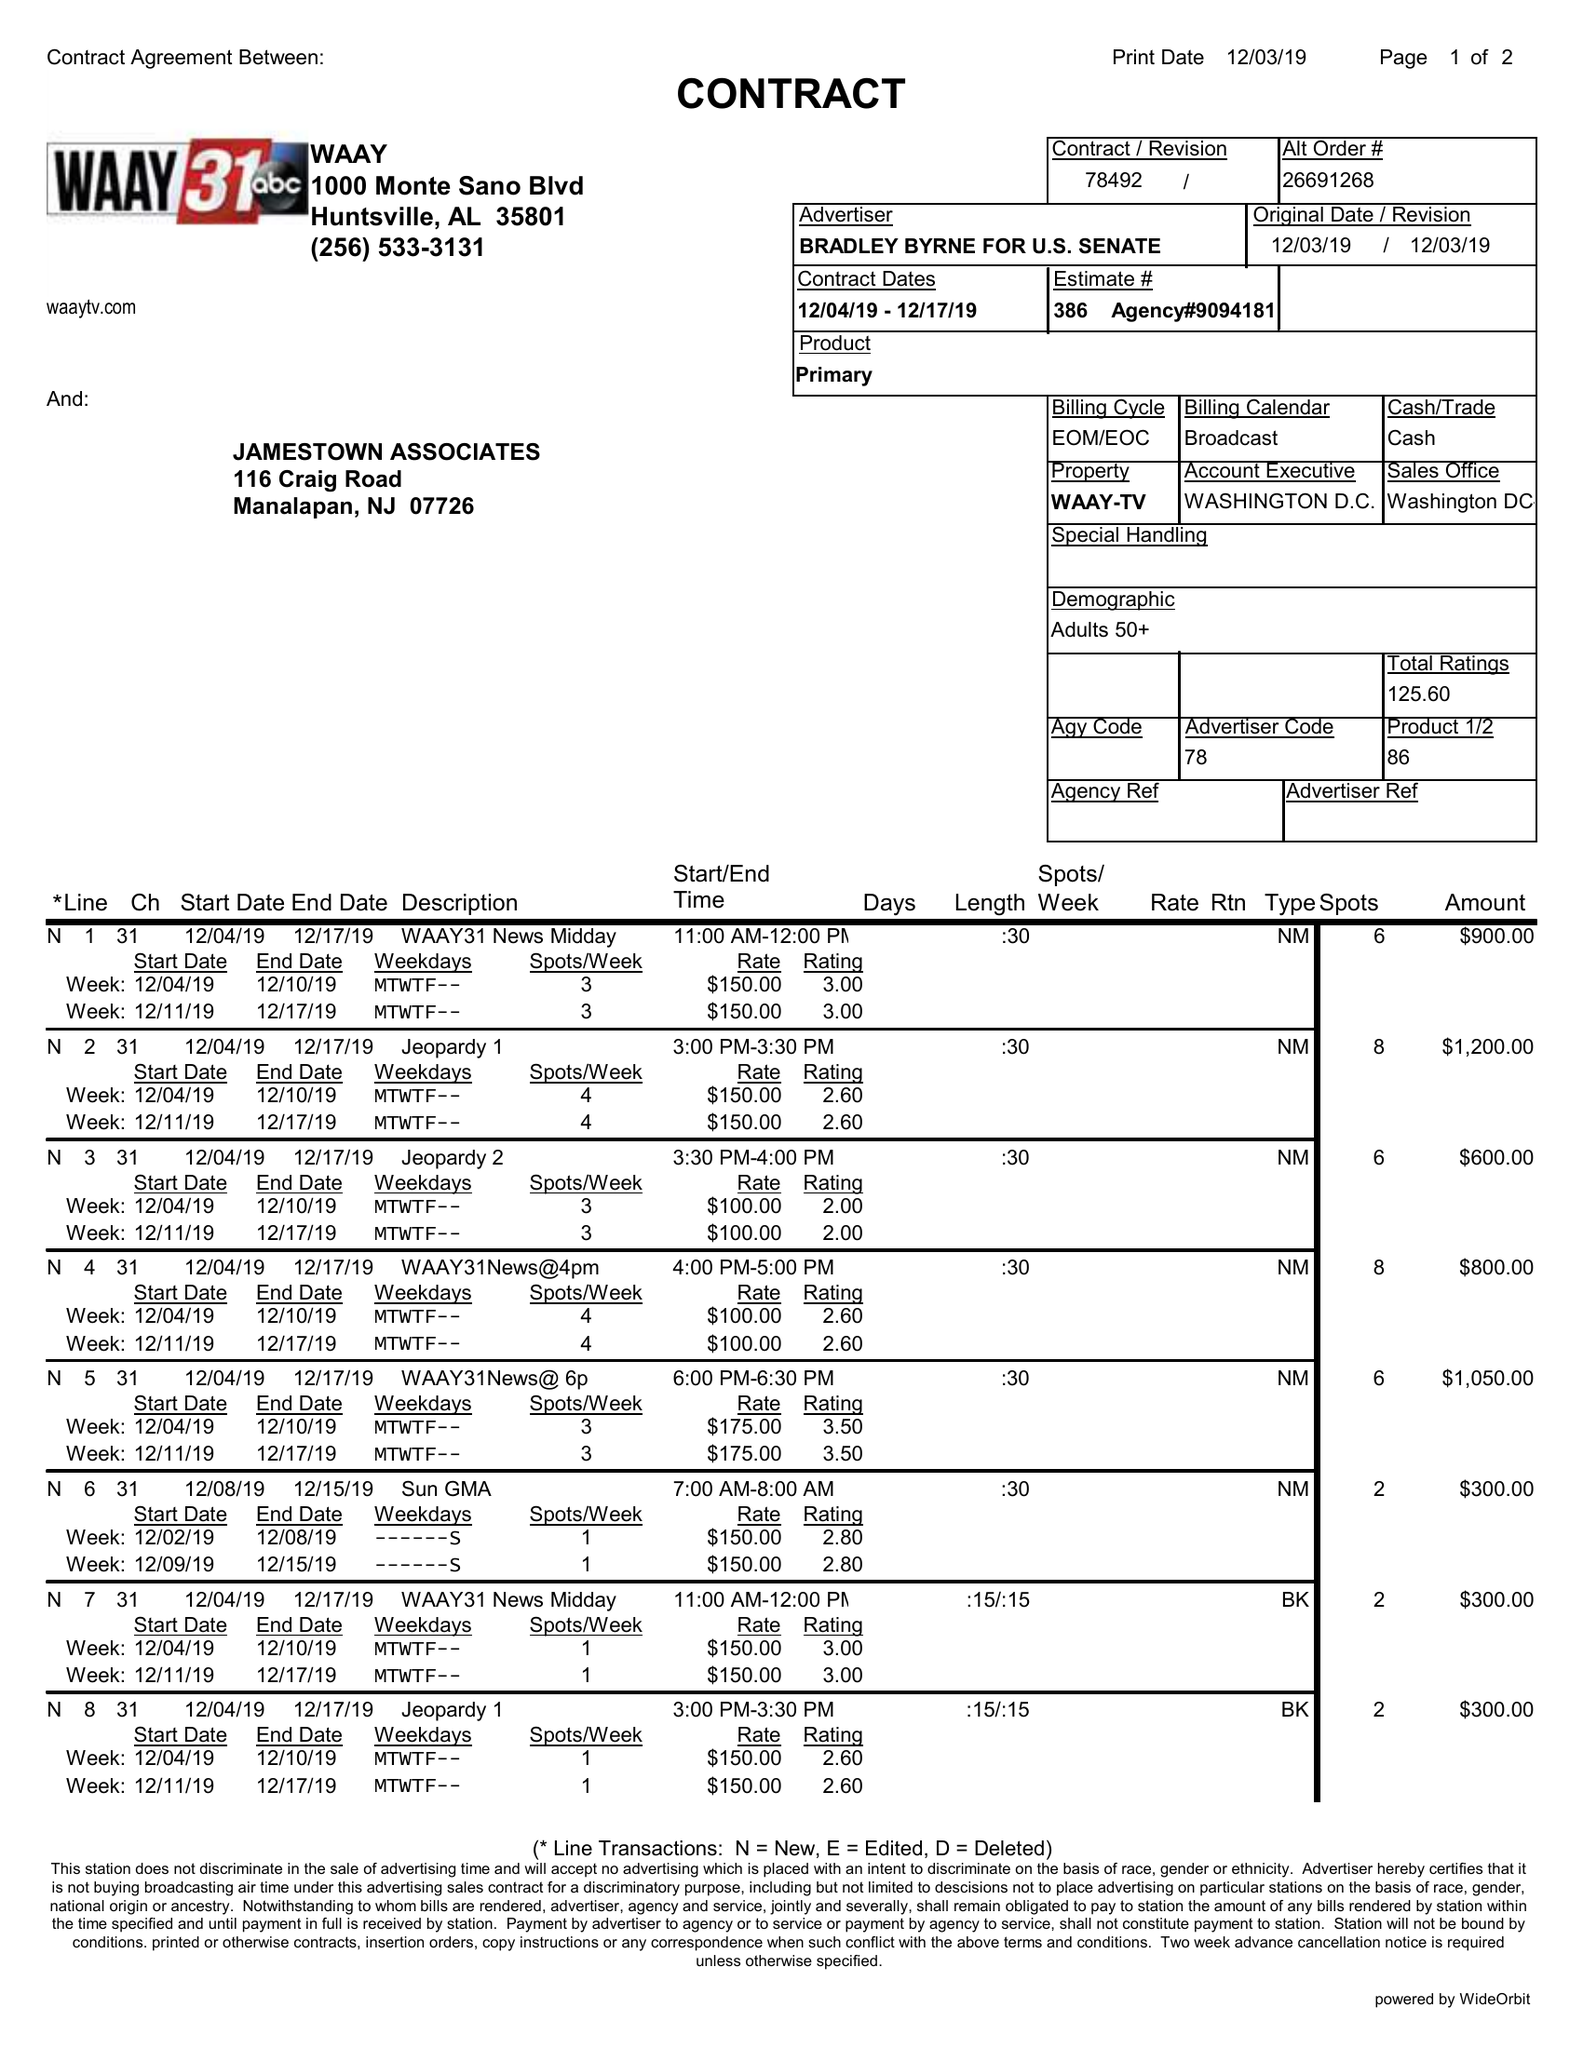What is the value for the gross_amount?
Answer the question using a single word or phrase. 6200.00 